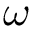Convert formula to latex. <formula><loc_0><loc_0><loc_500><loc_500>\omega</formula> 